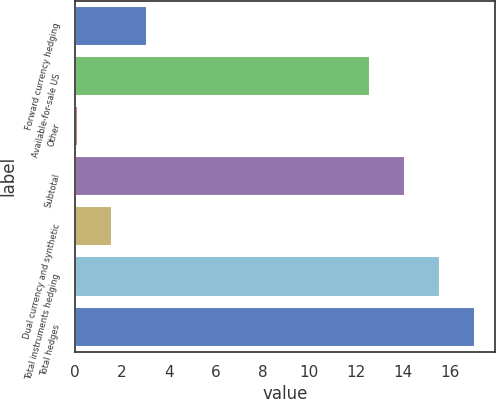<chart> <loc_0><loc_0><loc_500><loc_500><bar_chart><fcel>Forward currency hedging<fcel>Available-for-sale US<fcel>Other<fcel>Subtotal<fcel>Dual currency and synthetic<fcel>Total instruments hedging<fcel>Total hedges<nl><fcel>3.08<fcel>12.6<fcel>0.1<fcel>14.09<fcel>1.59<fcel>15.58<fcel>17.07<nl></chart> 